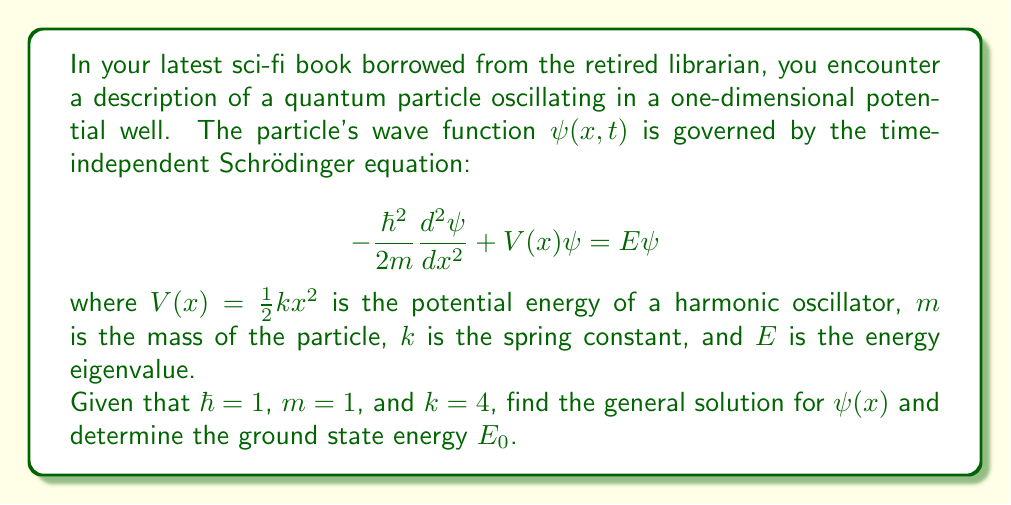Help me with this question. Let's approach this step-by-step:

1) First, we substitute the given values into the Schrödinger equation:

   $$-\frac{1}{2}\frac{d^2\psi}{dx^2} + 2x^2\psi = E\psi$$

2) Rearrange the equation:

   $$\frac{d^2\psi}{dx^2} + (2E - 4x^2)\psi = 0$$

3) This is a second-order linear differential equation. Its solution is of the form:

   $$\psi(x) = e^{-ax^2}H_n(bx)$$

   where $H_n$ is the nth Hermite polynomial, and $a$ and $b$ are constants to be determined.

4) Substituting this into our equation and comparing coefficients, we find:

   $a = 1$ and $b = \sqrt{2}$

5) Therefore, the general solution is:

   $$\psi_n(x) = A_n e^{-x^2}H_n(\sqrt{2}x)$$

   where $A_n$ is a normalization constant.

6) The energy eigenvalues are given by:

   $$E_n = \hbar\omega(n + \frac{1}{2})$$

   where $\omega = \sqrt{\frac{k}{m}} = 2$ in this case.

7) Therefore, the ground state energy ($n = 0$) is:

   $$E_0 = \frac{1}{2}\hbar\omega = 1$$
Answer: The general solution is $\psi_n(x) = A_n e^{-x^2}H_n(\sqrt{2}x)$, and the ground state energy is $E_0 = 1$. 